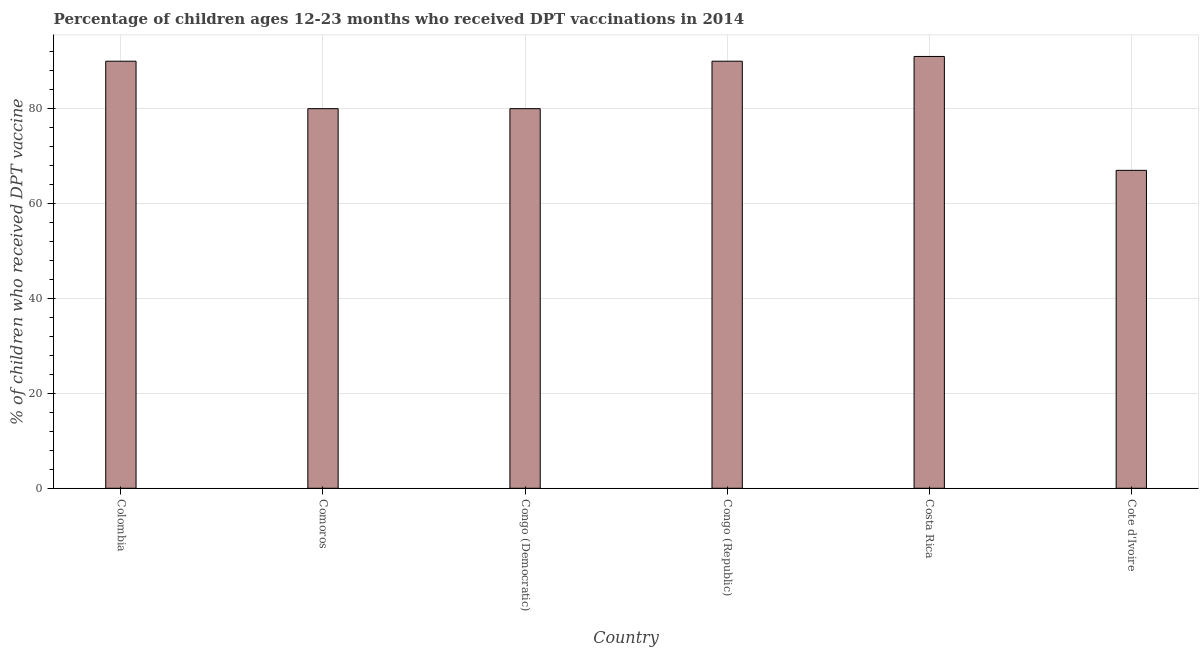What is the title of the graph?
Offer a terse response. Percentage of children ages 12-23 months who received DPT vaccinations in 2014. What is the label or title of the Y-axis?
Keep it short and to the point. % of children who received DPT vaccine. Across all countries, what is the maximum percentage of children who received dpt vaccine?
Your answer should be very brief. 91. In which country was the percentage of children who received dpt vaccine minimum?
Provide a short and direct response. Cote d'Ivoire. What is the sum of the percentage of children who received dpt vaccine?
Your answer should be very brief. 498. What is the difference between the percentage of children who received dpt vaccine in Colombia and Congo (Republic)?
Your response must be concise. 0. Is the difference between the percentage of children who received dpt vaccine in Comoros and Cote d'Ivoire greater than the difference between any two countries?
Offer a terse response. No. What is the difference between the highest and the second highest percentage of children who received dpt vaccine?
Your answer should be compact. 1. Is the sum of the percentage of children who received dpt vaccine in Congo (Republic) and Costa Rica greater than the maximum percentage of children who received dpt vaccine across all countries?
Provide a succinct answer. Yes. In how many countries, is the percentage of children who received dpt vaccine greater than the average percentage of children who received dpt vaccine taken over all countries?
Offer a terse response. 3. How many bars are there?
Keep it short and to the point. 6. Are all the bars in the graph horizontal?
Provide a short and direct response. No. What is the difference between two consecutive major ticks on the Y-axis?
Provide a short and direct response. 20. Are the values on the major ticks of Y-axis written in scientific E-notation?
Give a very brief answer. No. What is the % of children who received DPT vaccine in Colombia?
Give a very brief answer. 90. What is the % of children who received DPT vaccine of Comoros?
Give a very brief answer. 80. What is the % of children who received DPT vaccine in Costa Rica?
Ensure brevity in your answer.  91. What is the difference between the % of children who received DPT vaccine in Colombia and Congo (Democratic)?
Offer a very short reply. 10. What is the difference between the % of children who received DPT vaccine in Colombia and Congo (Republic)?
Offer a very short reply. 0. What is the difference between the % of children who received DPT vaccine in Colombia and Costa Rica?
Offer a terse response. -1. What is the difference between the % of children who received DPT vaccine in Comoros and Congo (Democratic)?
Offer a terse response. 0. What is the difference between the % of children who received DPT vaccine in Comoros and Cote d'Ivoire?
Offer a terse response. 13. What is the difference between the % of children who received DPT vaccine in Congo (Democratic) and Costa Rica?
Your answer should be very brief. -11. What is the difference between the % of children who received DPT vaccine in Congo (Republic) and Costa Rica?
Ensure brevity in your answer.  -1. What is the difference between the % of children who received DPT vaccine in Congo (Republic) and Cote d'Ivoire?
Your answer should be very brief. 23. What is the ratio of the % of children who received DPT vaccine in Colombia to that in Comoros?
Ensure brevity in your answer.  1.12. What is the ratio of the % of children who received DPT vaccine in Colombia to that in Congo (Democratic)?
Make the answer very short. 1.12. What is the ratio of the % of children who received DPT vaccine in Colombia to that in Congo (Republic)?
Your response must be concise. 1. What is the ratio of the % of children who received DPT vaccine in Colombia to that in Costa Rica?
Keep it short and to the point. 0.99. What is the ratio of the % of children who received DPT vaccine in Colombia to that in Cote d'Ivoire?
Your response must be concise. 1.34. What is the ratio of the % of children who received DPT vaccine in Comoros to that in Congo (Democratic)?
Make the answer very short. 1. What is the ratio of the % of children who received DPT vaccine in Comoros to that in Congo (Republic)?
Offer a very short reply. 0.89. What is the ratio of the % of children who received DPT vaccine in Comoros to that in Costa Rica?
Provide a succinct answer. 0.88. What is the ratio of the % of children who received DPT vaccine in Comoros to that in Cote d'Ivoire?
Provide a succinct answer. 1.19. What is the ratio of the % of children who received DPT vaccine in Congo (Democratic) to that in Congo (Republic)?
Your answer should be very brief. 0.89. What is the ratio of the % of children who received DPT vaccine in Congo (Democratic) to that in Costa Rica?
Ensure brevity in your answer.  0.88. What is the ratio of the % of children who received DPT vaccine in Congo (Democratic) to that in Cote d'Ivoire?
Provide a succinct answer. 1.19. What is the ratio of the % of children who received DPT vaccine in Congo (Republic) to that in Costa Rica?
Offer a terse response. 0.99. What is the ratio of the % of children who received DPT vaccine in Congo (Republic) to that in Cote d'Ivoire?
Give a very brief answer. 1.34. What is the ratio of the % of children who received DPT vaccine in Costa Rica to that in Cote d'Ivoire?
Provide a short and direct response. 1.36. 